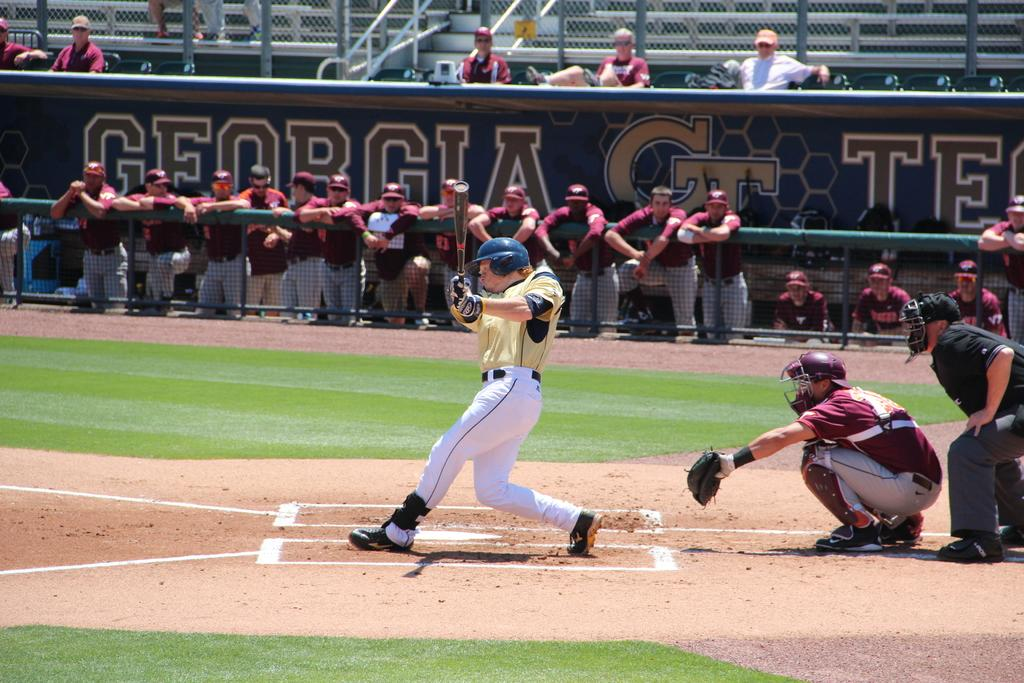<image>
Provide a brief description of the given image. A batter swings as the players on the other team watch in front of a "Georgia" sign. 